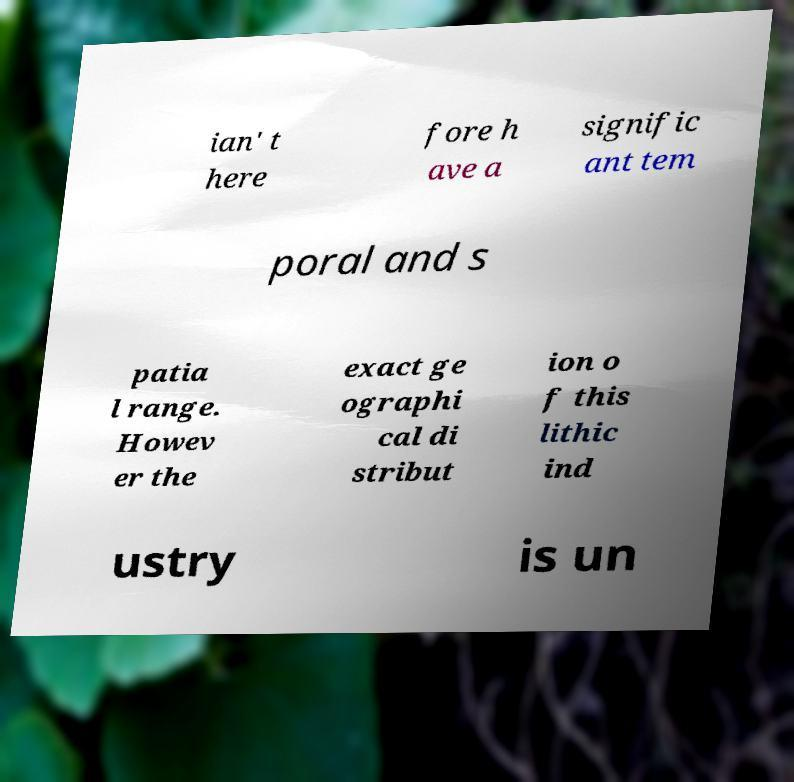Could you extract and type out the text from this image? ian' t here fore h ave a signific ant tem poral and s patia l range. Howev er the exact ge ographi cal di stribut ion o f this lithic ind ustry is un 